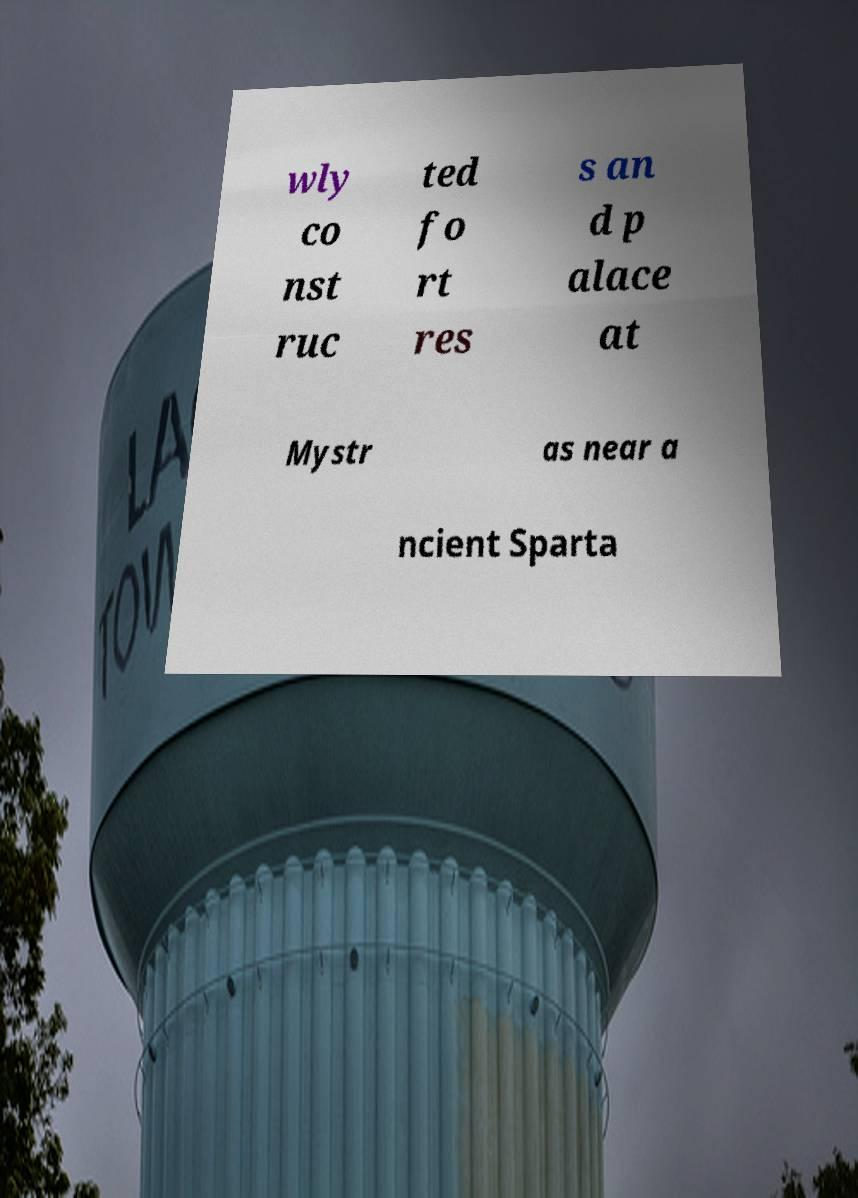There's text embedded in this image that I need extracted. Can you transcribe it verbatim? wly co nst ruc ted fo rt res s an d p alace at Mystr as near a ncient Sparta 